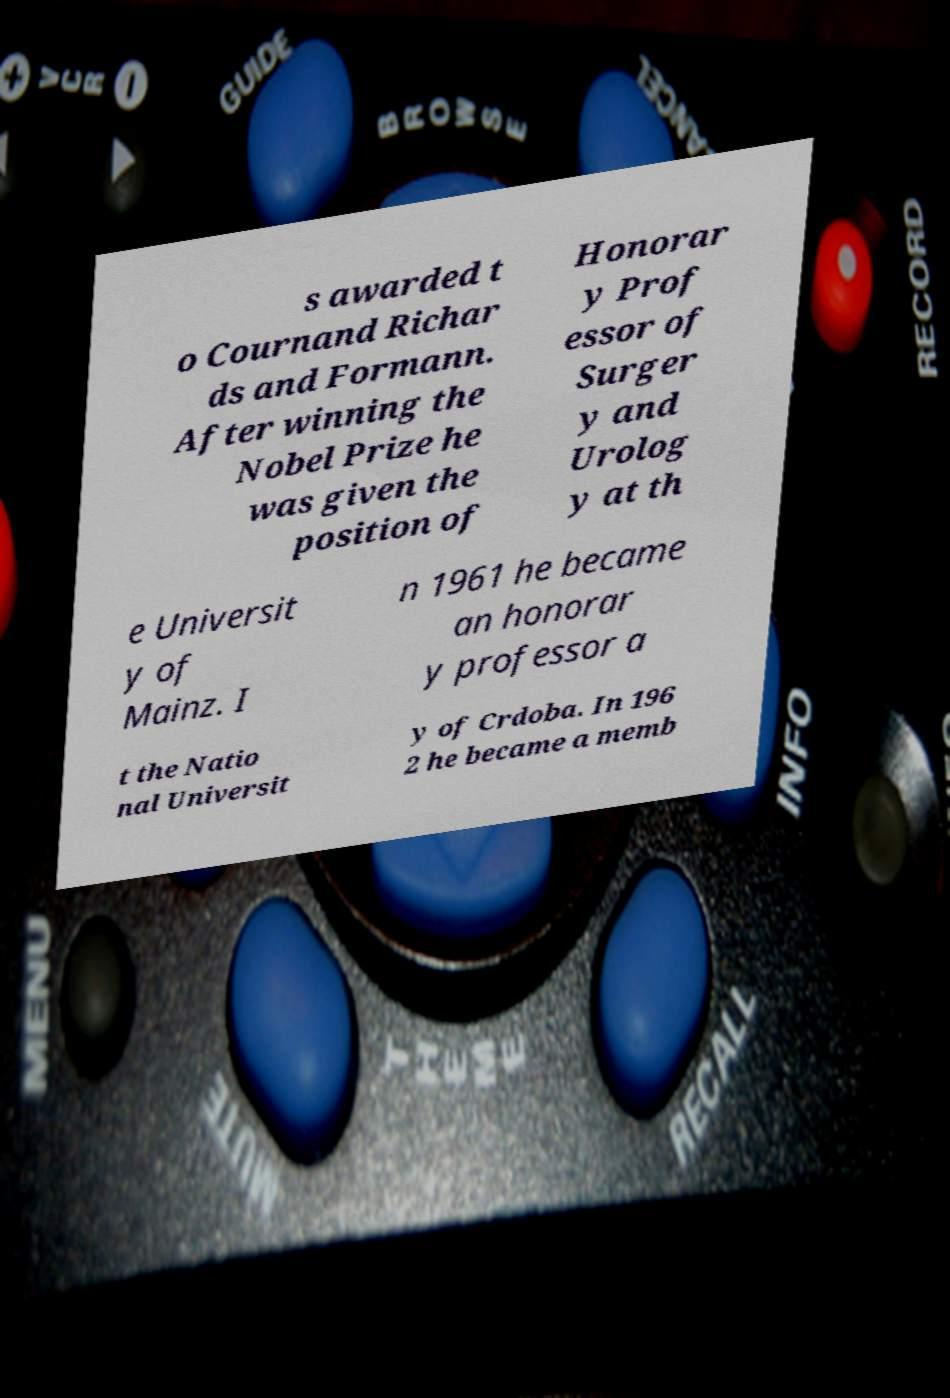What messages or text are displayed in this image? I need them in a readable, typed format. s awarded t o Cournand Richar ds and Formann. After winning the Nobel Prize he was given the position of Honorar y Prof essor of Surger y and Urolog y at th e Universit y of Mainz. I n 1961 he became an honorar y professor a t the Natio nal Universit y of Crdoba. In 196 2 he became a memb 